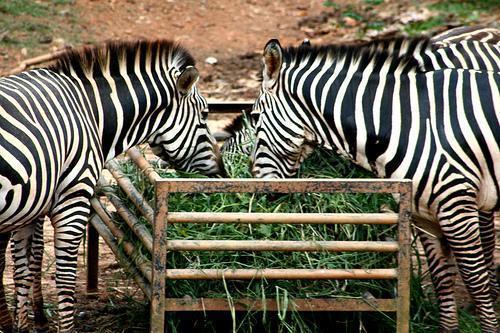How many zebras are pictured?
Give a very brief answer. 2. How many zebras are eating grass?
Give a very brief answer. 2. 